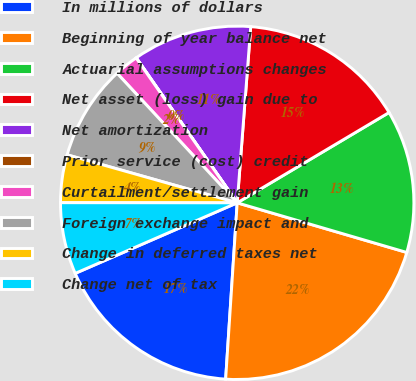Convert chart to OTSL. <chart><loc_0><loc_0><loc_500><loc_500><pie_chart><fcel>In millions of dollars<fcel>Beginning of year balance net<fcel>Actuarial assumptions changes<fcel>Net asset (loss) gain due to<fcel>Net amortization<fcel>Prior service (cost) credit<fcel>Curtailment/settlement gain<fcel>Foreign exchange impact and<fcel>Change in deferred taxes net<fcel>Change net of tax<nl><fcel>17.42%<fcel>21.51%<fcel>13.07%<fcel>15.24%<fcel>10.9%<fcel>0.02%<fcel>2.2%<fcel>8.72%<fcel>4.37%<fcel>6.55%<nl></chart> 